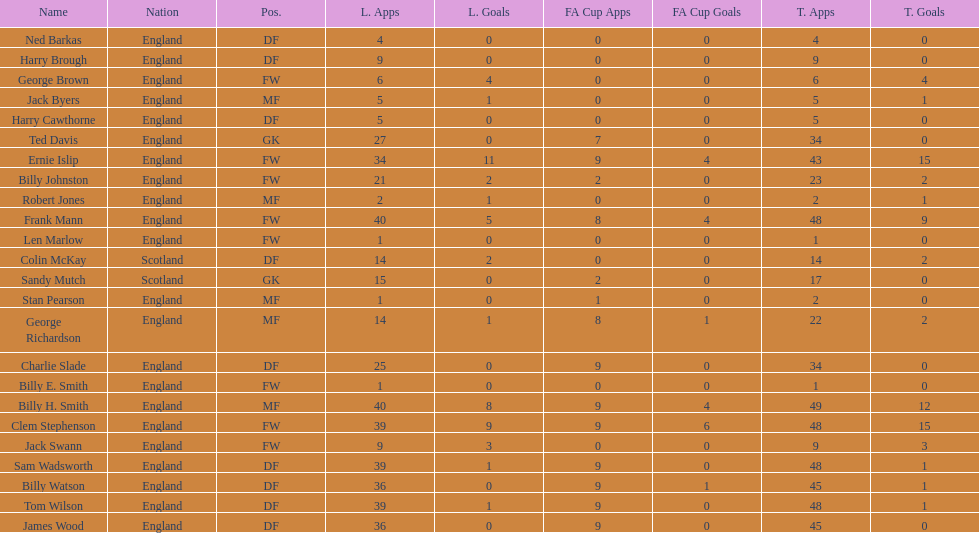What is the first name listed? Ned Barkas. 